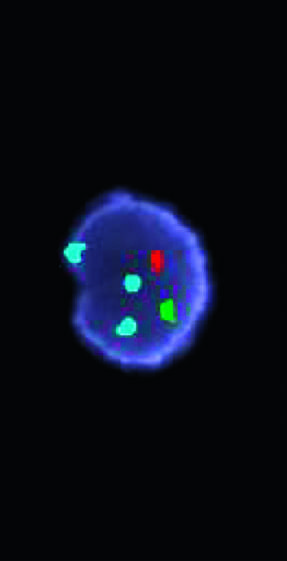have the segregation of b cells and t cells in different regions of the lymph node been used in a fish cocktail?
Answer the question using a single word or phrase. No 